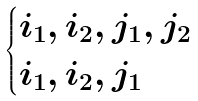<formula> <loc_0><loc_0><loc_500><loc_500>\begin{cases} i _ { 1 } , i _ { 2 } , j _ { 1 } , j _ { 2 } \\ i _ { 1 } , i _ { 2 } , j _ { 1 } \end{cases}</formula> 